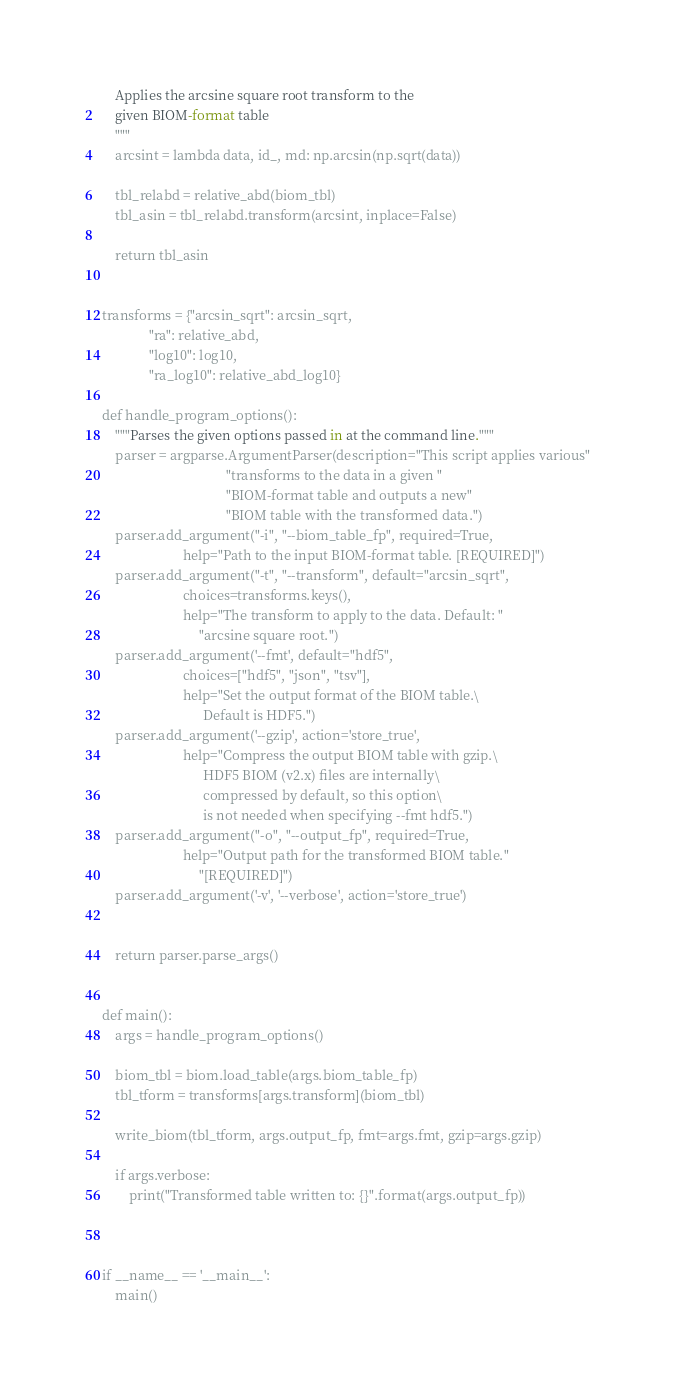Convert code to text. <code><loc_0><loc_0><loc_500><loc_500><_Python_>    Applies the arcsine square root transform to the
    given BIOM-format table
    """
    arcsint = lambda data, id_, md: np.arcsin(np.sqrt(data))

    tbl_relabd = relative_abd(biom_tbl)
    tbl_asin = tbl_relabd.transform(arcsint, inplace=False)

    return tbl_asin


transforms = {"arcsin_sqrt": arcsin_sqrt, 
              "ra": relative_abd, 
              "log10": log10, 
              "ra_log10": relative_abd_log10}

def handle_program_options():
    """Parses the given options passed in at the command line."""
    parser = argparse.ArgumentParser(description="This script applies various"
                                     "transforms to the data in a given "
                                     "BIOM-format table and outputs a new"
                                     "BIOM table with the transformed data.")
    parser.add_argument("-i", "--biom_table_fp", required=True,
                        help="Path to the input BIOM-format table. [REQUIRED]")
    parser.add_argument("-t", "--transform", default="arcsin_sqrt", 
                        choices=transforms.keys(),
                        help="The transform to apply to the data. Default: "
                             "arcsine square root.")
    parser.add_argument('--fmt', default="hdf5", 
                        choices=["hdf5", "json", "tsv"],
                        help="Set the output format of the BIOM table.\
                              Default is HDF5.")
    parser.add_argument('--gzip', action='store_true',
                        help="Compress the output BIOM table with gzip.\
                              HDF5 BIOM (v2.x) files are internally\
                              compressed by default, so this option\
                              is not needed when specifying --fmt hdf5.")
    parser.add_argument("-o", "--output_fp", required=True,
                        help="Output path for the transformed BIOM table."
                             "[REQUIRED]")
    parser.add_argument('-v', '--verbose', action='store_true')


    return parser.parse_args()


def main():
    args = handle_program_options()

    biom_tbl = biom.load_table(args.biom_table_fp)
    tbl_tform = transforms[args.transform](biom_tbl)

    write_biom(tbl_tform, args.output_fp, fmt=args.fmt, gzip=args.gzip)

    if args.verbose:
        print("Transformed table written to: {}".format(args.output_fp))



if __name__ == '__main__':
    main()</code> 